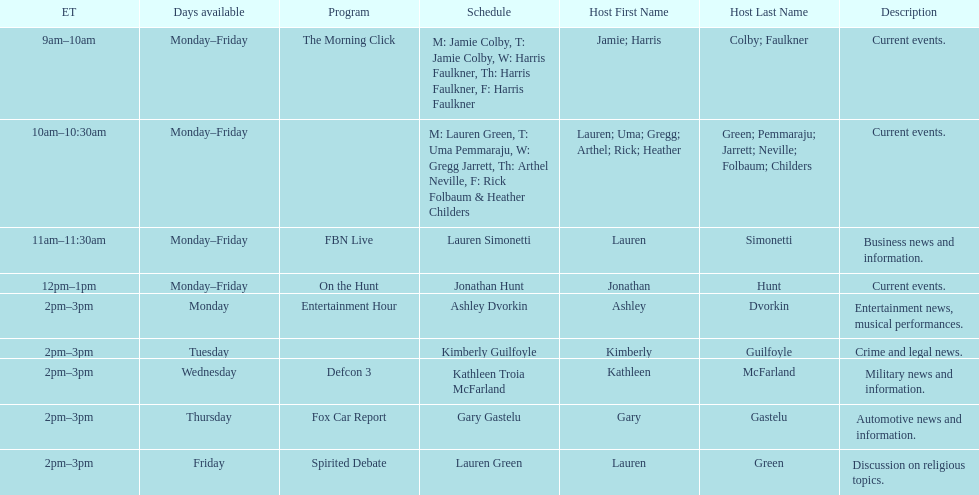What is the first show to play on monday mornings? The Morning Click. 